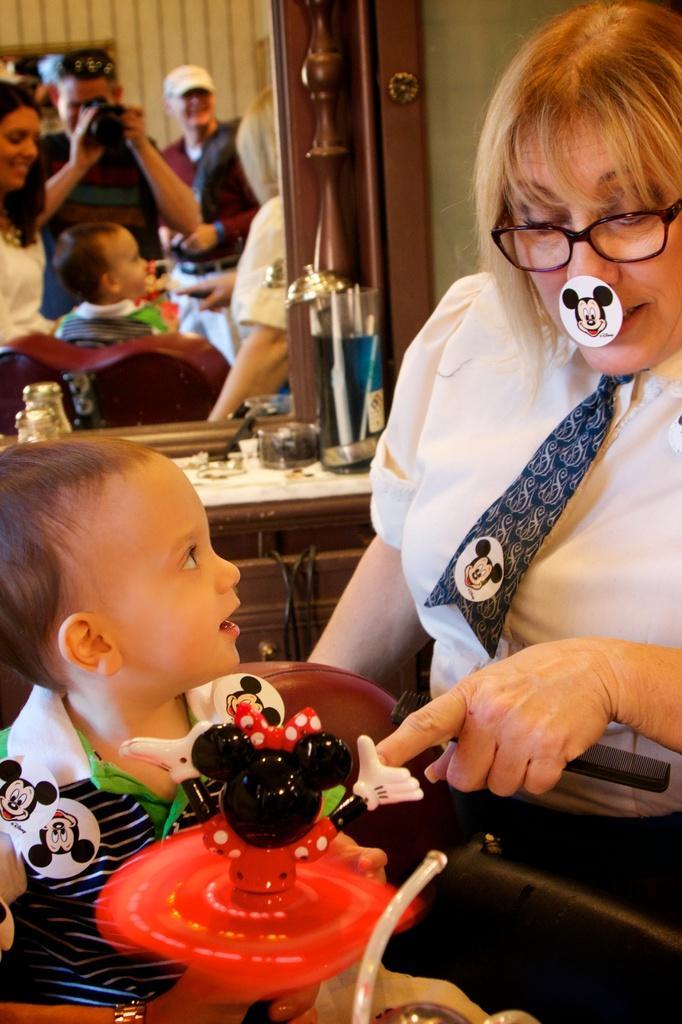Can you describe this image briefly? On the left side, there is a baby sitting and holding a toy. On the right side, there is a woman in a white color t-shirt, wearing a spectacle and having a sticker on her nose. In the background, there is a mirror, some objects on a cupboard and there is a wall. 